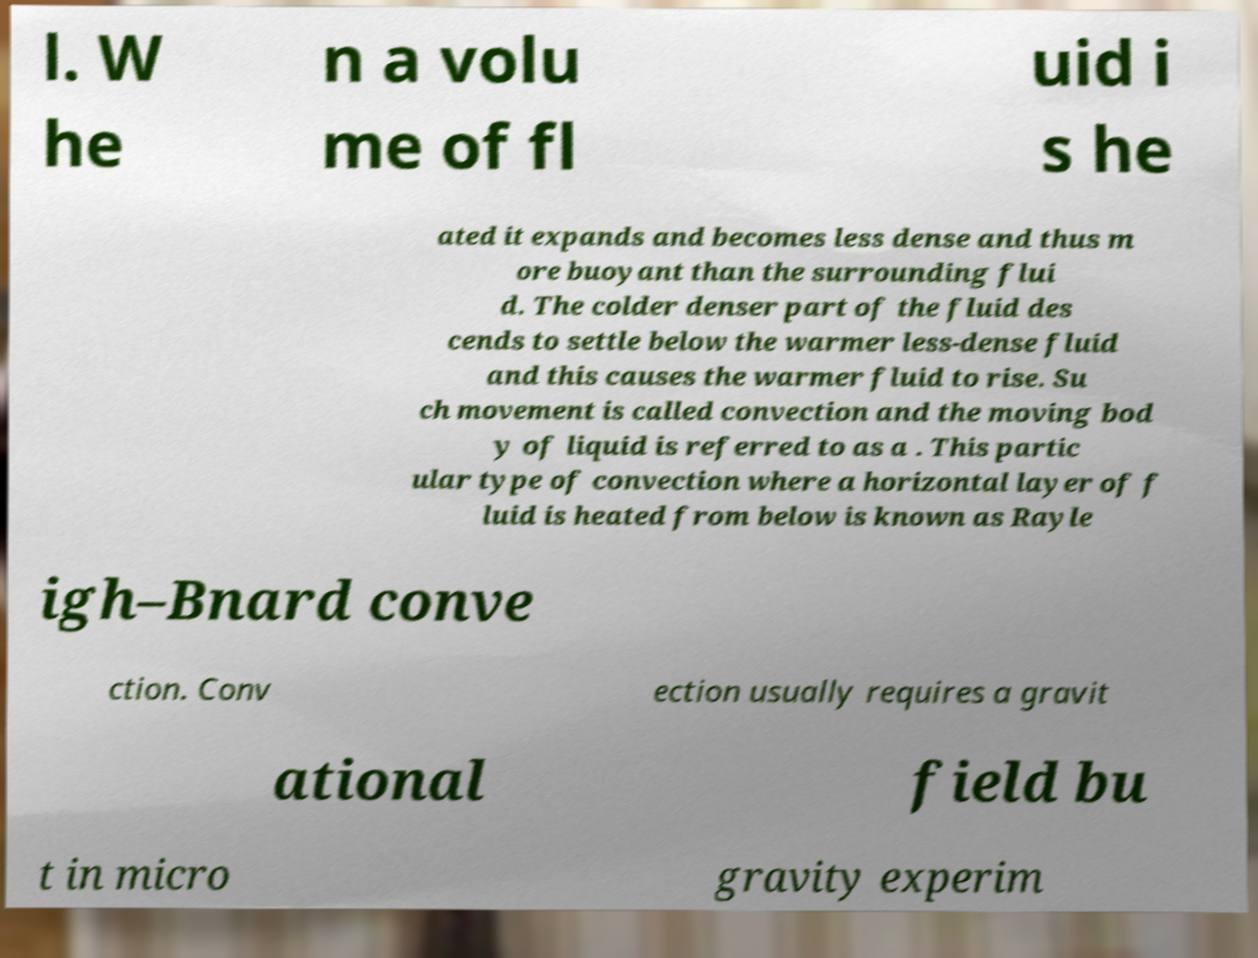Please identify and transcribe the text found in this image. l. W he n a volu me of fl uid i s he ated it expands and becomes less dense and thus m ore buoyant than the surrounding flui d. The colder denser part of the fluid des cends to settle below the warmer less-dense fluid and this causes the warmer fluid to rise. Su ch movement is called convection and the moving bod y of liquid is referred to as a . This partic ular type of convection where a horizontal layer of f luid is heated from below is known as Rayle igh–Bnard conve ction. Conv ection usually requires a gravit ational field bu t in micro gravity experim 